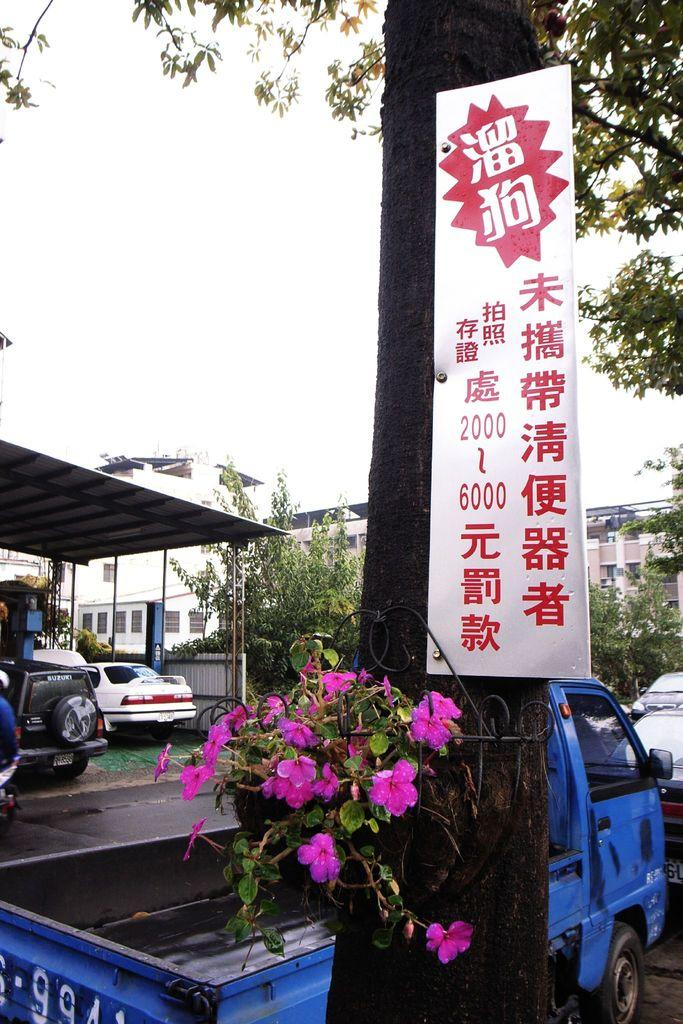What is the main object in the image? There is a white board in the image. What type of flowers can be seen in the image? There are pink flowers in the image. What can be seen on the road in the image? Vehicles are visible on the road in the image. What is located on the left side of the image? There is a shed on the left side of the image. What is present at the back of the image? Trees and buildings are present at the back of the image. What type of quilt is being used to cover the vehicles in the image? There is no quilt present in the image, and the vehicles are not covered. Can you see a laborer working on the white board in the image? There is no laborer present in the image, and no work is being done on the white board. 